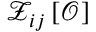<formula> <loc_0><loc_0><loc_500><loc_500>{ \mathcal { Z } _ { i j } \left [ \mathcal { O } \right ] }</formula> 